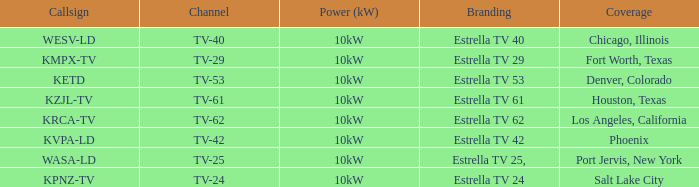Which city did kpnz-tv provide coverage for? Salt Lake City. 